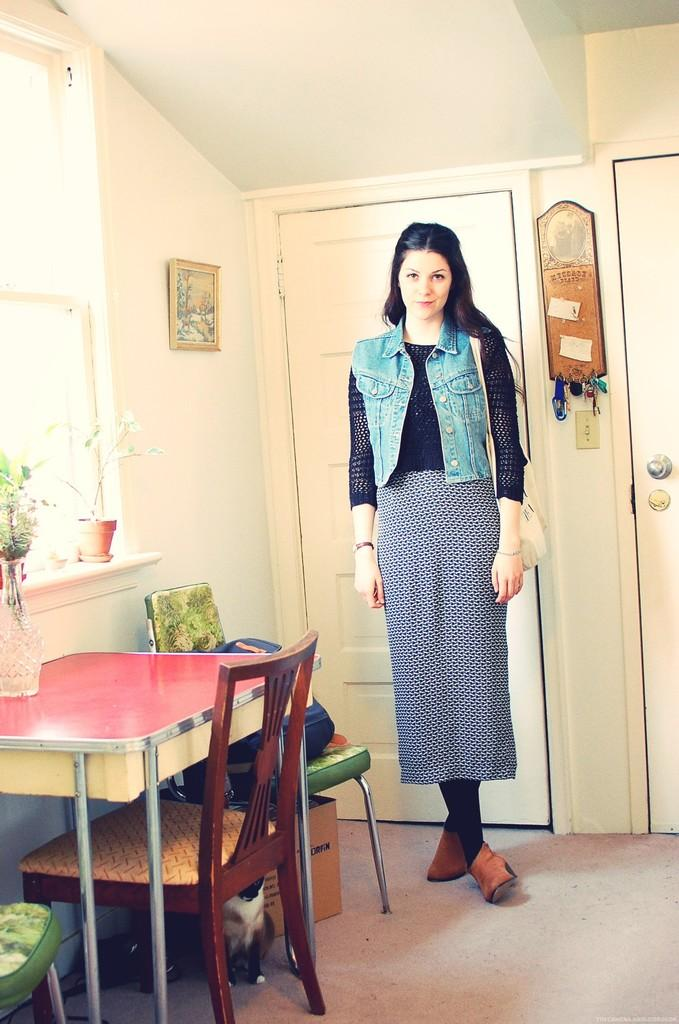What is the primary subject in the image? There is a woman standing in the image. On which side of the image is the woman standing? The woman is standing on the left side. What can be seen in the background of the image? There is a dining table, a door, and a wall in the background of the image. What type of attraction can be seen on the woman's wrist in the image? There is no attraction visible on the woman's wrist in the image. What is the woman rubbing on the wall in the image? The woman is not rubbing anything on the wall in the image. 